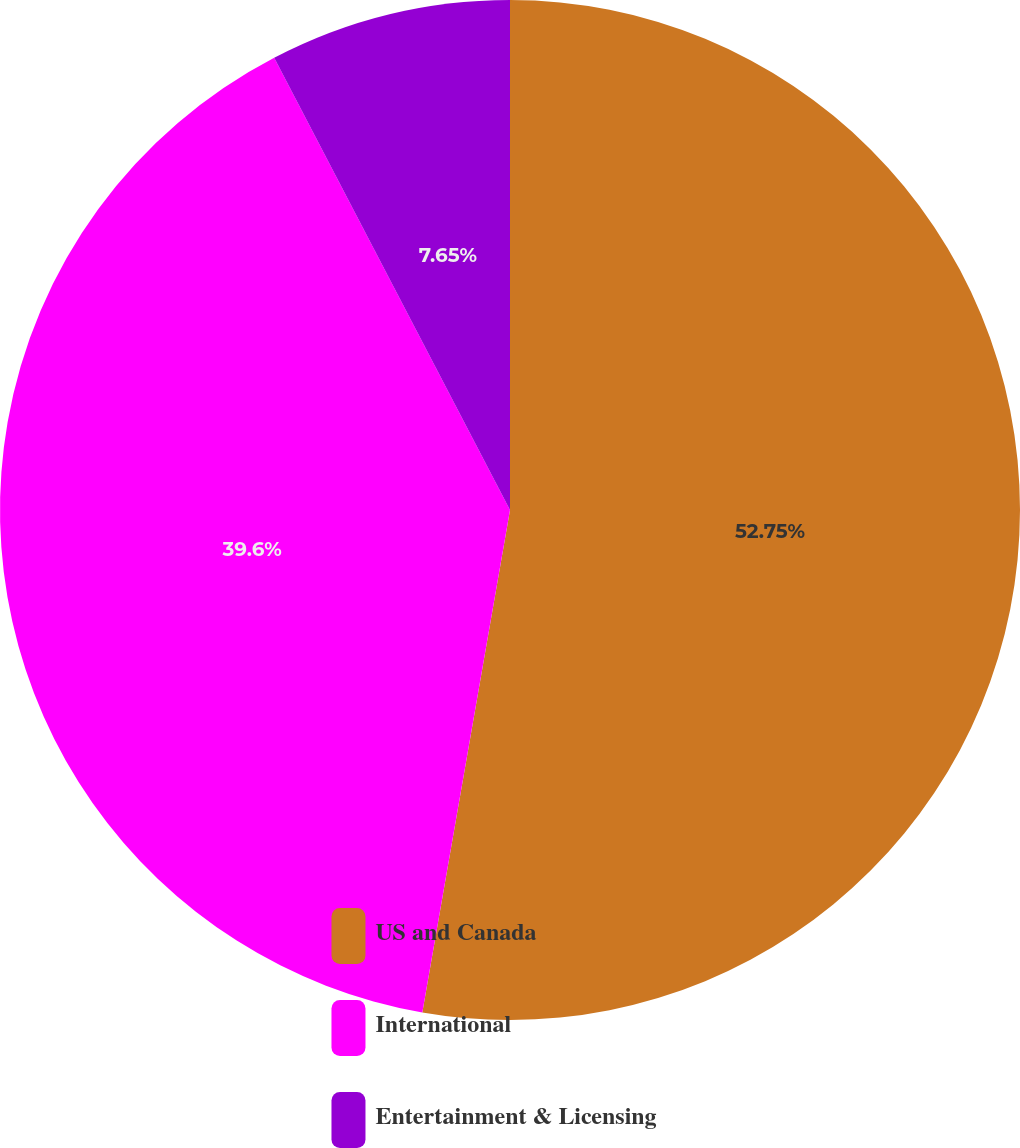Convert chart. <chart><loc_0><loc_0><loc_500><loc_500><pie_chart><fcel>US and Canada<fcel>International<fcel>Entertainment & Licensing<nl><fcel>52.75%<fcel>39.6%<fcel>7.65%<nl></chart> 